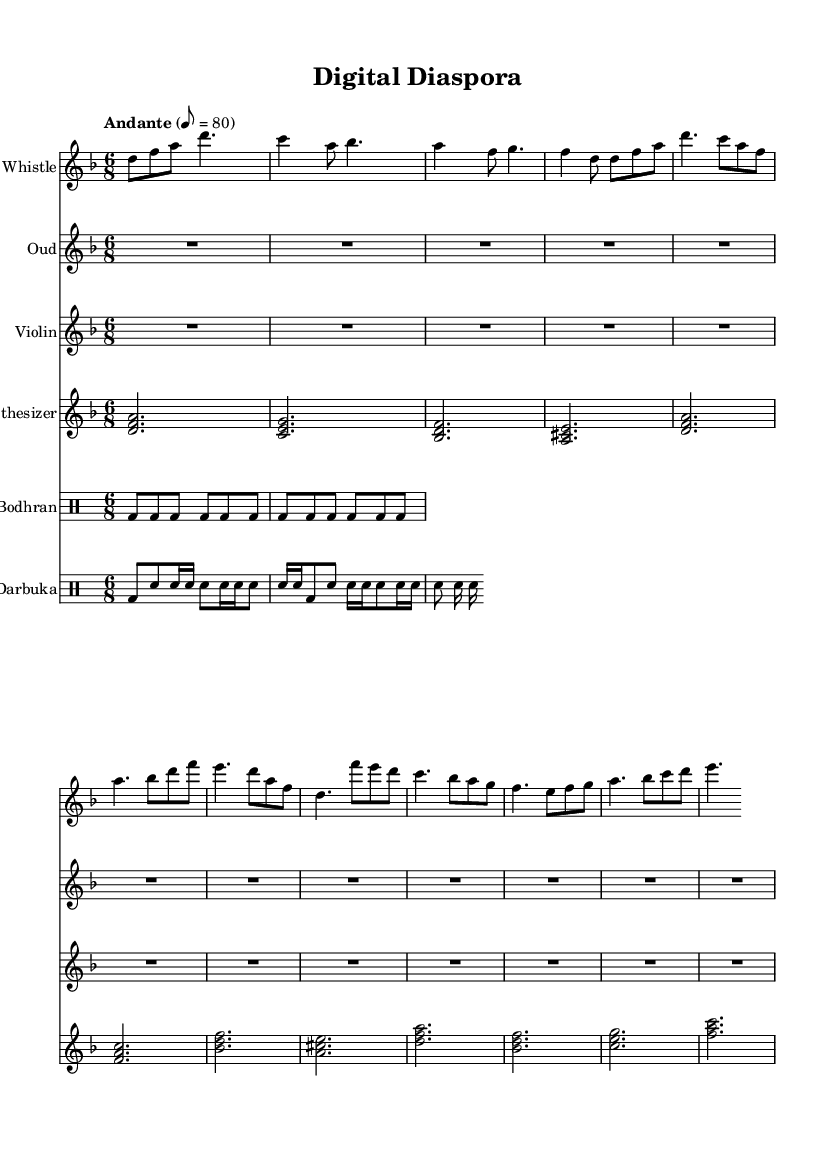What is the key signature of this music? The key signature is D minor, as indicated by the one flat (B flat) and the use of the D tonic throughout the piece.
Answer: D minor What is the time signature of the piece? The time signature is 6/8, which indicates the piece is in compound duple meter, and each measure contains six eighth notes.
Answer: 6/8 What is the tempo marking for the music? The tempo marking is "Andante," which suggests a tempo that is moderately slow and relaxed, typically around 76 to 108 beats per minute.
Answer: Andante How many distinct instrument parts are shown in the score? The score includes five distinct instrument parts: Irish Whistle, Oud, Violin, Synthesizer, and two types of drums (Bodhran and Darbuka).
Answer: Five Which instrument plays the main melodic line in the chorus section? The main melodic line in the chorus section is primarily played by the Irish Whistle, as it has the most prominent and catchy melodies.
Answer: Irish Whistle What is the rhythmic pattern used by the Bodhran? The Bodhran follows a steady pattern of bass drum hits, denoted by "bd," indicating a repetitive rhythmic motif that drives the piece forward.
Answer: bd8 bd bd bd bd bd How does the Synthesizer contribute to the texture of the music? The Synthesizer provides harmonic support through chord voicings, enhancing the overall texture by filling in the harmonic gaps left by the other melodic instruments.
Answer: Harmonic support 